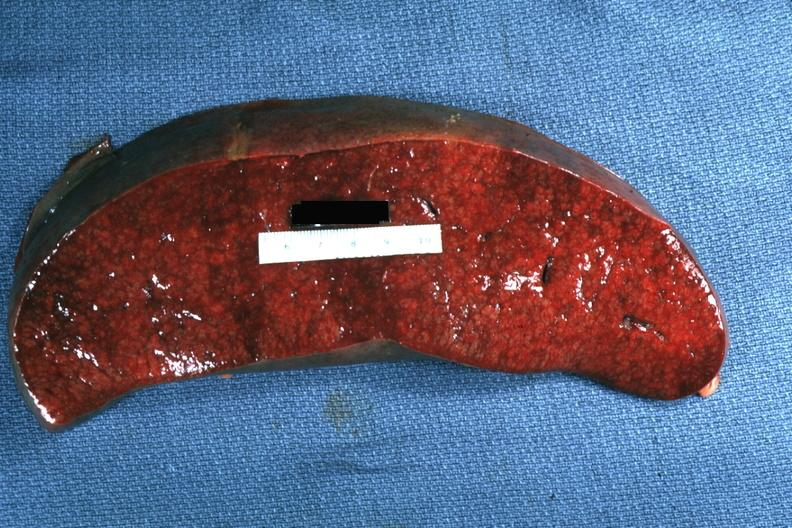what is present?
Answer the question using a single word or phrase. Hematologic 